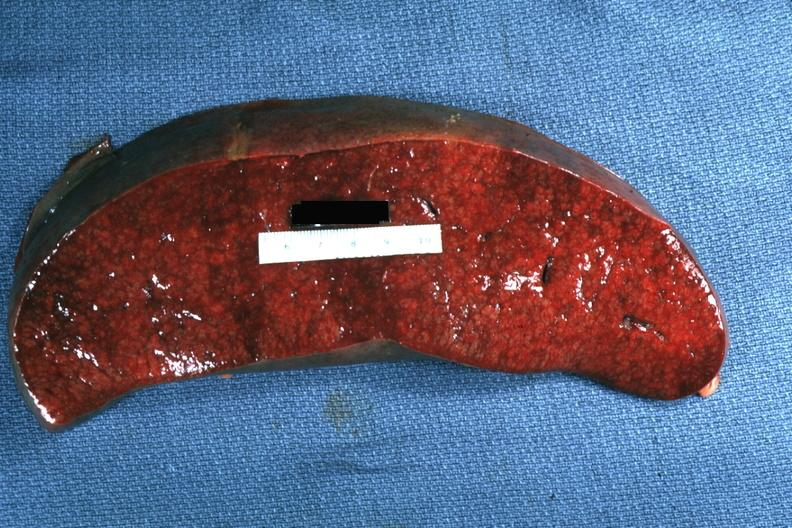what is present?
Answer the question using a single word or phrase. Hematologic 